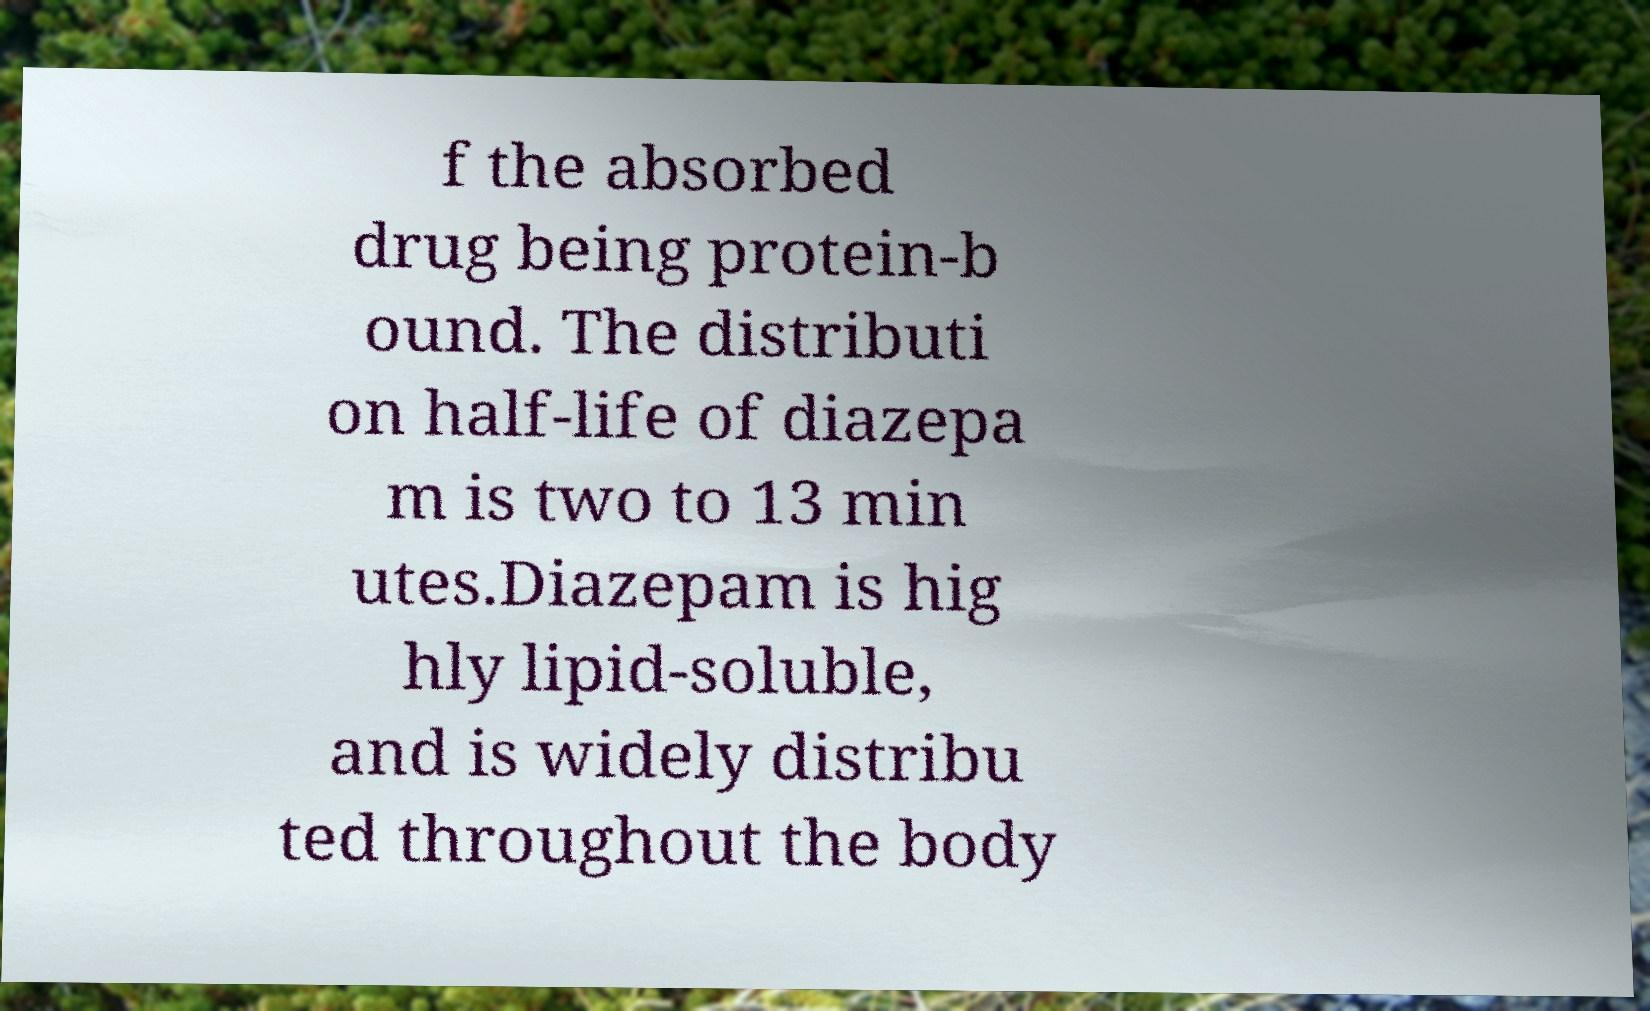I need the written content from this picture converted into text. Can you do that? f the absorbed drug being protein-b ound. The distributi on half-life of diazepa m is two to 13 min utes.Diazepam is hig hly lipid-soluble, and is widely distribu ted throughout the body 